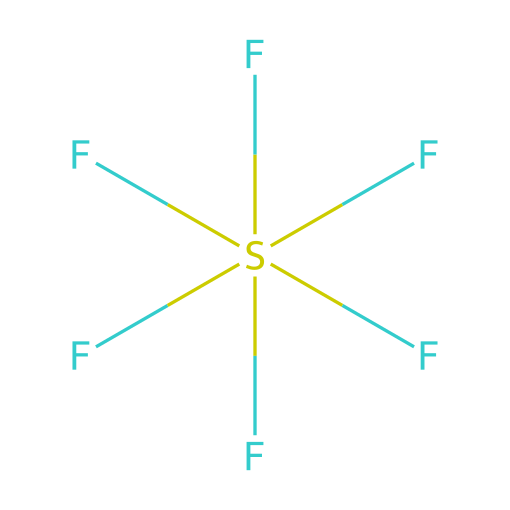What is the central atom in this compound? The chemical structure shows that sulfur (S) is surrounded by six fluorine (F) atoms, indicating that sulfur is the central atom connecting all the fluorine atoms.
Answer: sulfur How many fluorine atoms are in this molecule? By examining the structure, we can see there are six fluorine (F) atoms bonded to the sulfur (S) atom.
Answer: six What type of bonding occurs in this compound? The structure indicates covalent bonding, as sulfur shares electrons with each of the six fluorine atoms to form stable bonds.
Answer: covalent What is the hybridization of the central sulfur atom? Given that sulfur is bonded to six fluorine atoms in a symmetrical arrangement, the hybridization is sp3d2, allowing for an octahedral geometry.
Answer: sp3d2 How many bonds does sulfur form in this compound? There are six bonds connecting sulfur to each of the fluorine atoms, which shows the number of bonds formed by the sulfur atom in the structure.
Answer: six Is this compound an example of a hypervalent species? Yes, this compound is classified as hypervalent because the central sulfur atom has more than the typical octet of electrons, specifically accommodating twelve electrons from six bonds.
Answer: yes What geometry does this compound have? The arrangement of the fluorine atoms around the central sulfur atom gives the compound an octahedral geometry, which is typical for compounds with sp3d2 hybridization.
Answer: octahedral 